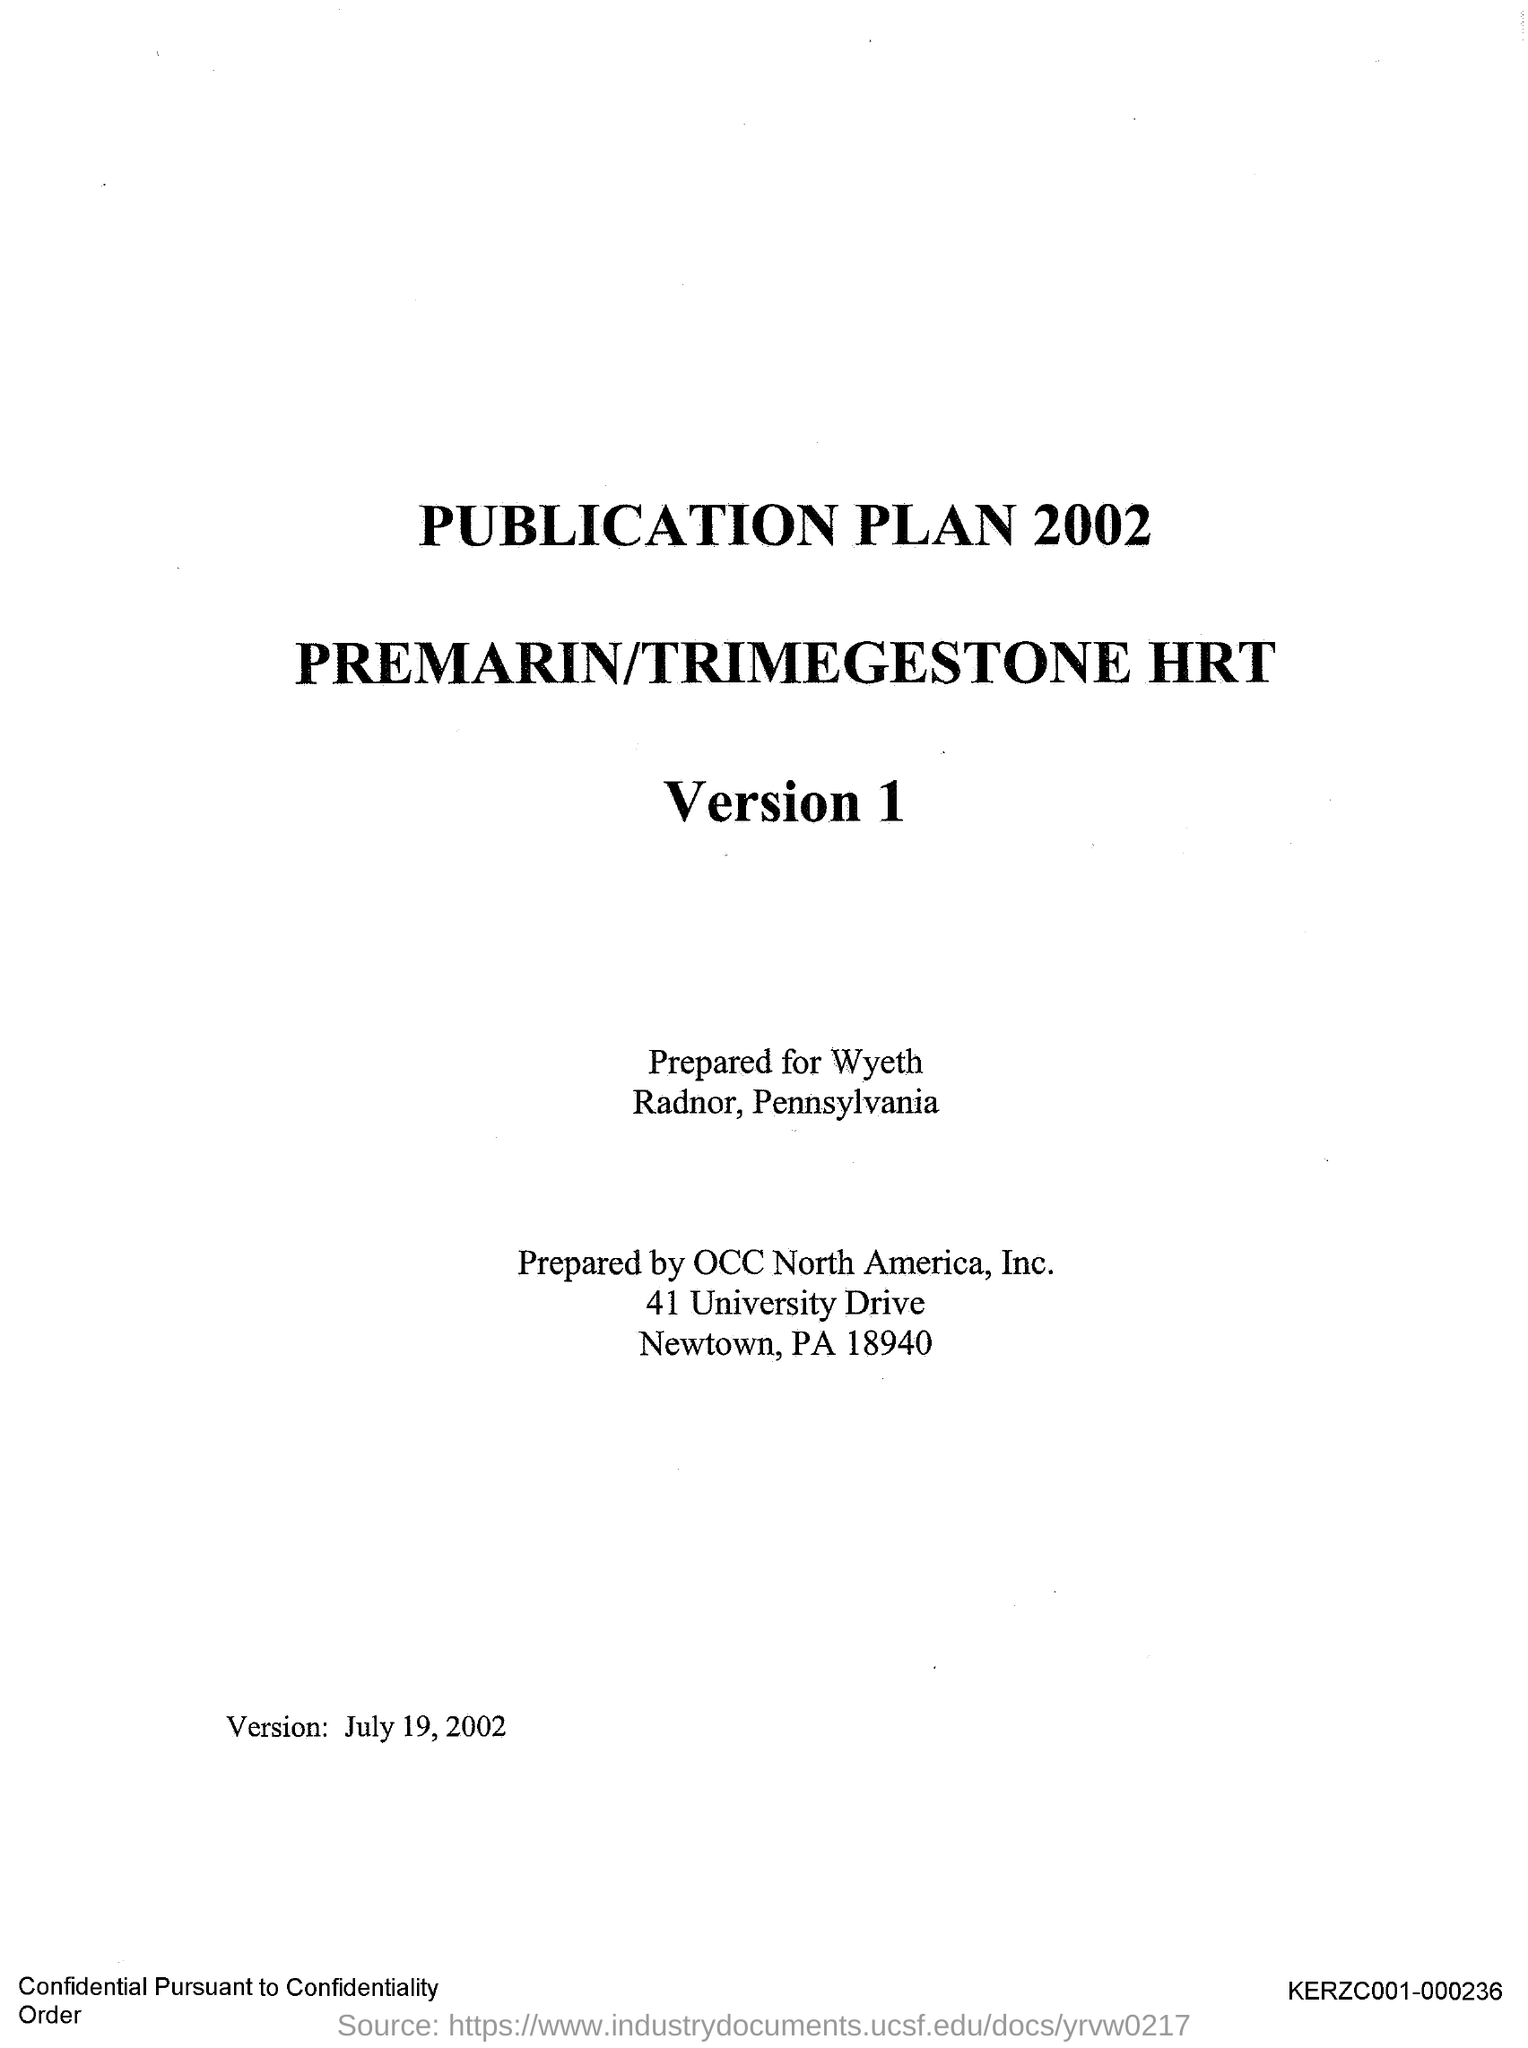What is the first title in the document?
Your response must be concise. Publication plan 2002. What is the second title in this document?
Make the answer very short. Premarin/Trimegestone HRT. What is the third title in the document?
Your answer should be very brief. Version 1. The document is prepared for which company?
Your response must be concise. Wyeth. The document is prepared by which company?
Offer a terse response. OCC North America, Inc. 